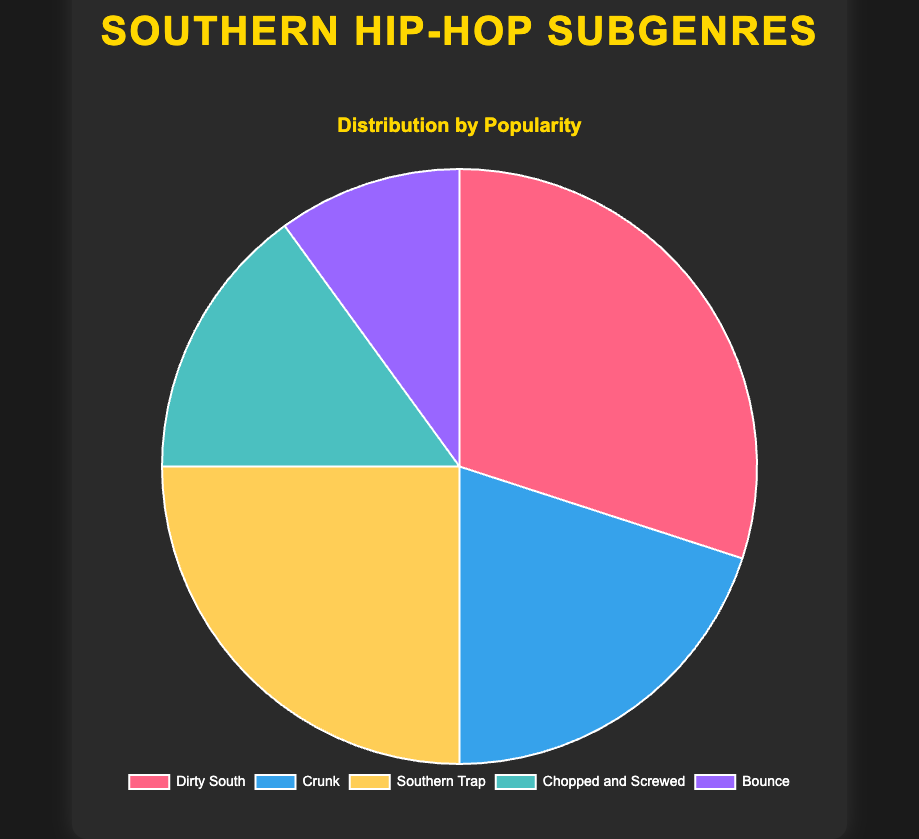What percentage of the chart does Dirty South occupy? Dirty South occupies a section colored in pink, labeled with 30%.
Answer: 30% Which subgenre is least popular? The least popular subgenre is the one with the smallest percentage slice, colored purple and labeled Bounce at 10%.
Answer: Bounce How much more popular is Dirty South compared to Bounce? Dirty South has a percentage of 30%, while Bounce has 10%. Calculating the difference: 30% - 10% = 20%.
Answer: 20% What are the two most popular subgenres combined percentage? The two largest slices are Dirty South at 30% and Southern Trap at 25%. Adding these together: 30% + 25% = 55%.
Answer: 55% If you group Bounce, Chopped and Screwed, and Crunk together, what percentage of the distribution do they cover? Bounce is 10%, Chopped and Screwed is 15%, and Crunk is 20%. Summing these: 10% + 15% + 20% = 45%.
Answer: 45% Is Southern Trap more popular than Crunk? Comparing the percentages of Southern Trap (25%) and Crunk (20%), Southern Trap is more popular.
Answer: Yes What is the average percentage popularity of all subgenres? The percentages are 30%, 20%, 25%, 15%, and 10%. Adding these totals: 30 + 20 + 25 + 15 + 10 = 100. Dividing by the number of subgenres (5): 100 / 5 = 20%.
Answer: 20% Which subgenre uses the yellow slice in the chart? The yellow slice represents Southern Trap.
Answer: Southern Trap How does the popularity of Chopped and Screwed compare to the combined popularity of Bounce and Crunk? Chopped and Screwed is 15%, Bounce is 10%, and Crunk is 20%. Combining Bounce and Crunk: 10% + 20% = 30%. Since 15% is less than 30%, Chopped and Screwed is less popular.
Answer: Less 